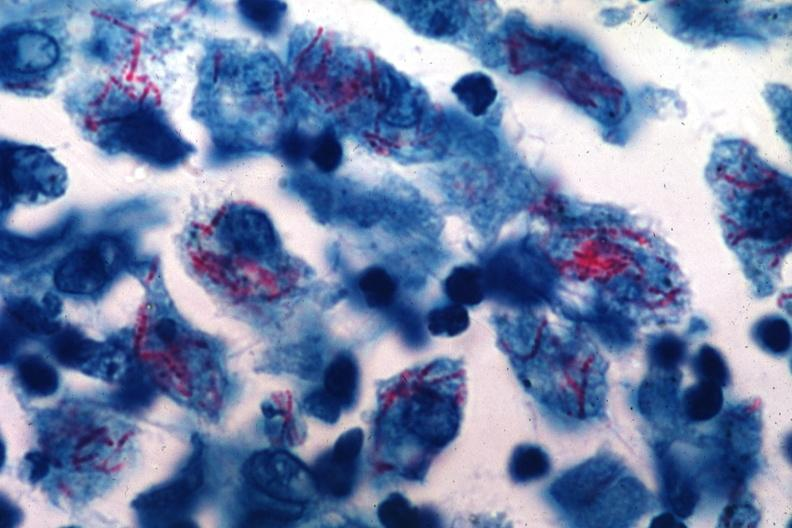s lymph node present?
Answer the question using a single word or phrase. Yes 